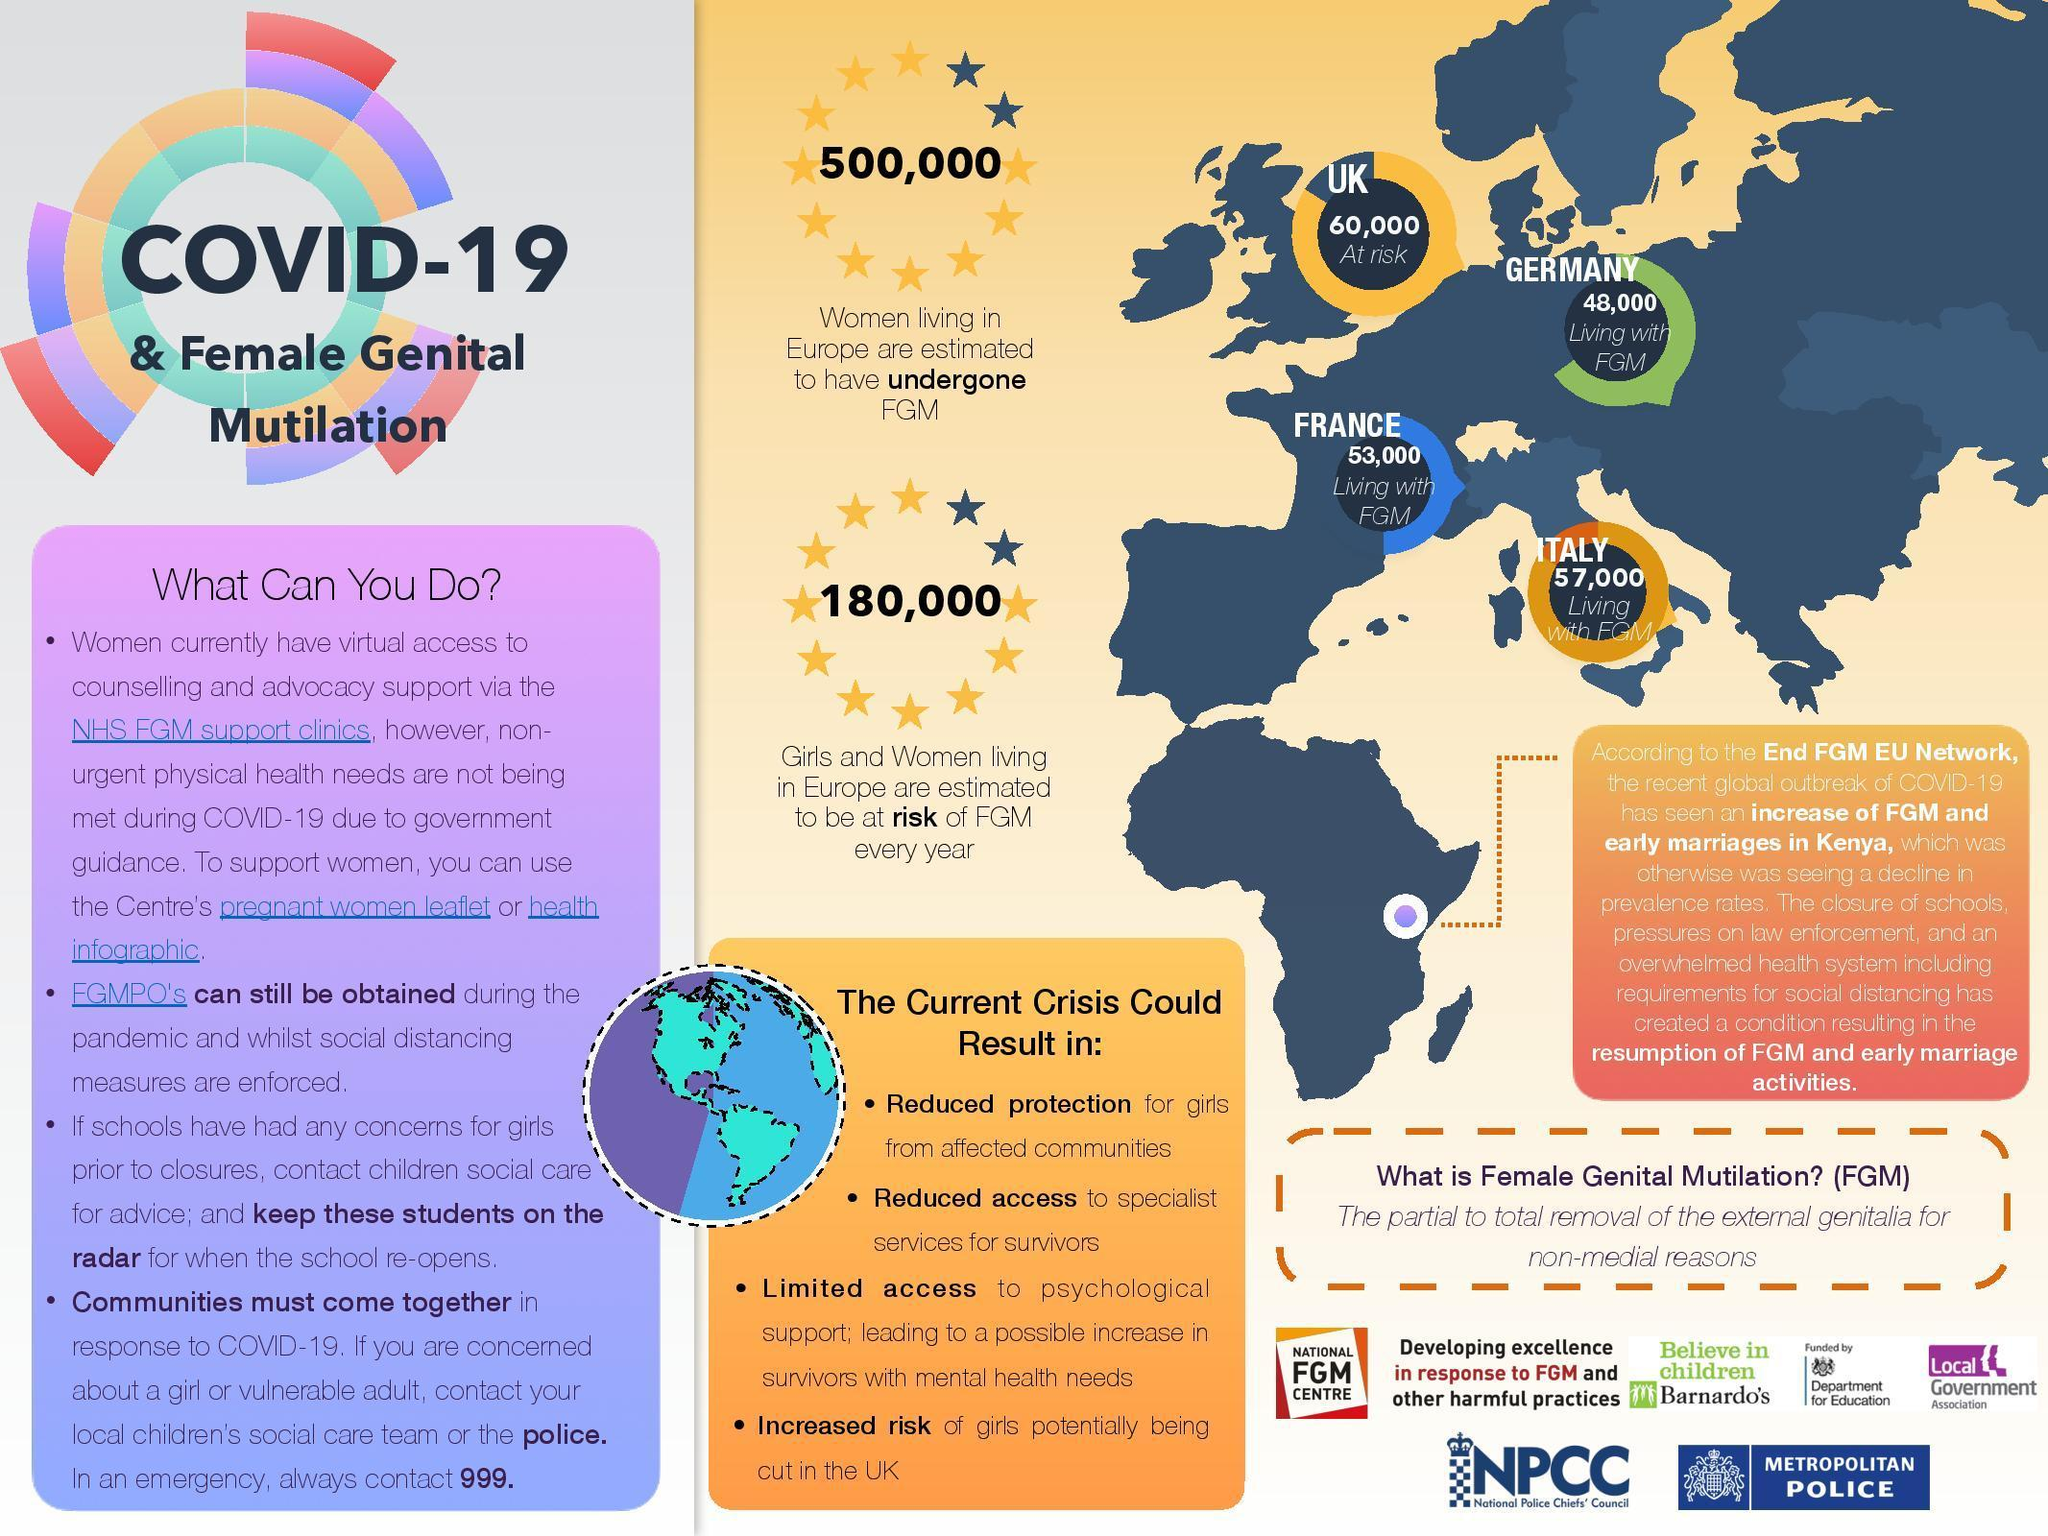How many country names are in this infographic?
Answer the question with a short phrase. 4 How many women living in Europe are estimated to have undergone FGV? 500,000 